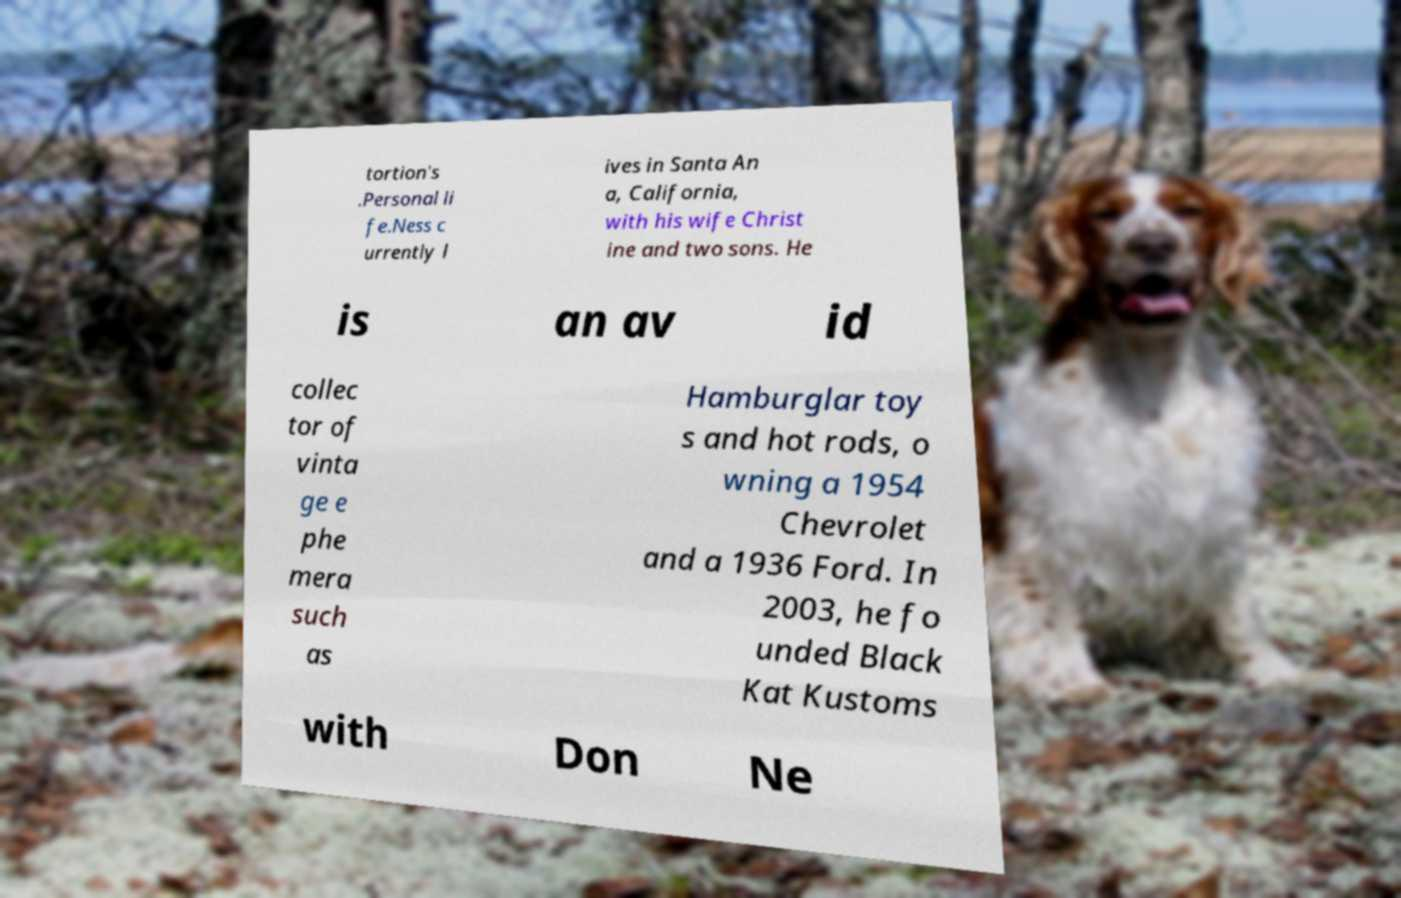Could you extract and type out the text from this image? tortion's .Personal li fe.Ness c urrently l ives in Santa An a, California, with his wife Christ ine and two sons. He is an av id collec tor of vinta ge e phe mera such as Hamburglar toy s and hot rods, o wning a 1954 Chevrolet and a 1936 Ford. In 2003, he fo unded Black Kat Kustoms with Don Ne 